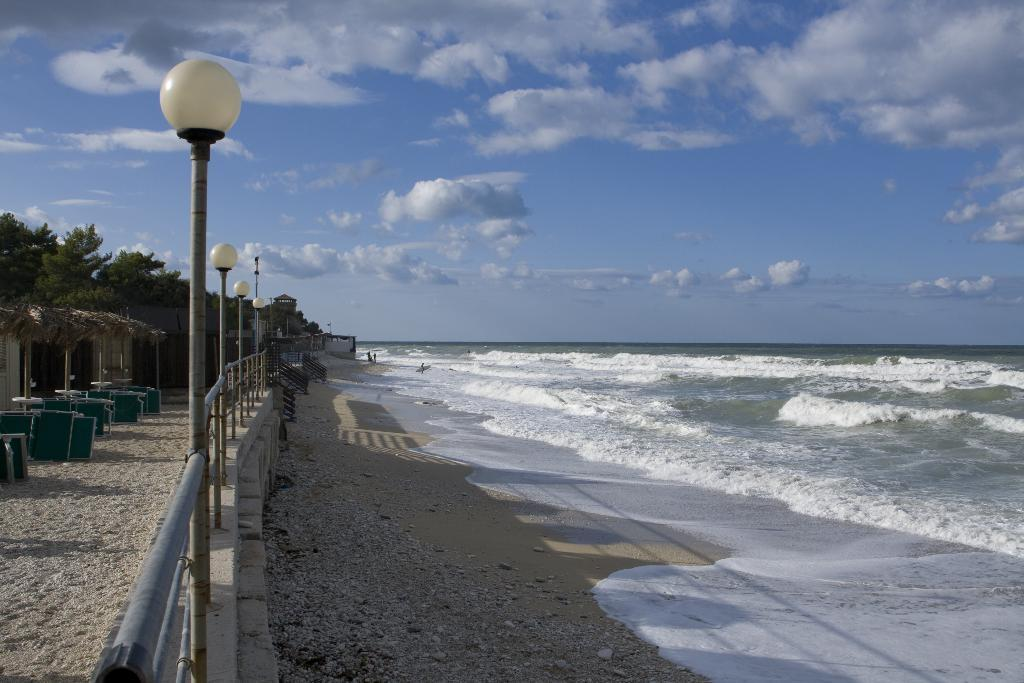What type of natural element is present in the image? There is water in the image. What type of terrain is visible in the image? There is sand in the image. What type of structure can be seen in the image? There is a fence in the image. What type of vertical supports are present in the image? There are poles in the image. What type of lighting fixtures are present in the image? There are lamps in the image. What type of vegetation is visible in the image? There are trees in the image. What type of objects are present in the image? There are objects in the image. What is visible in the background of the image? The sky is visible in the background of the image. What type of atmospheric phenomena can be seen in the sky? There are clouds in the sky. Where is the hydrant located in the image? There is no hydrant present in the image. What type of current can be seen flowing through the water in the image? There is no current visible in the water in the image. 